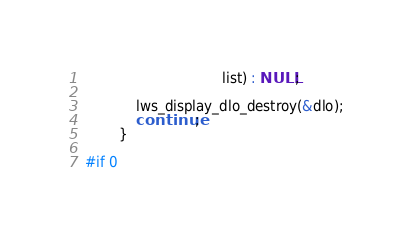Convert code to text. <code><loc_0><loc_0><loc_500><loc_500><_C_>								list) : NULL;

			lws_display_dlo_destroy(&dlo);
			continue;
		}

#if 0</code> 